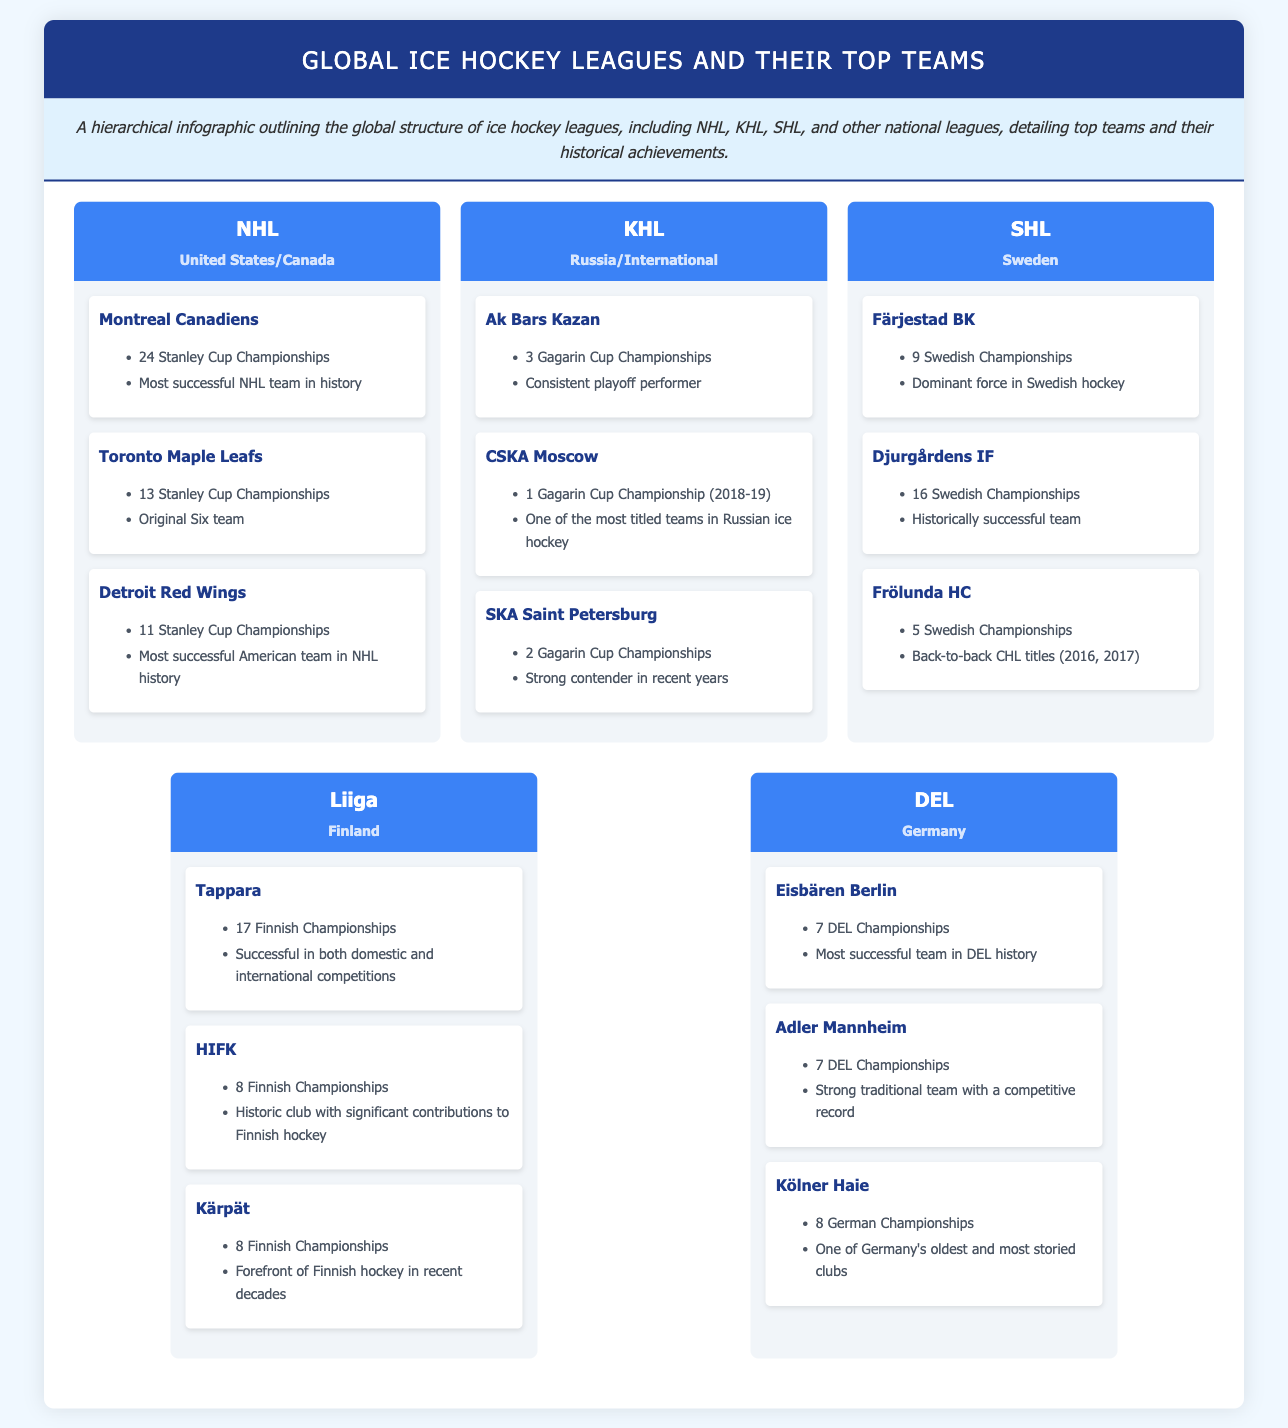What league is known for having 24 Stanley Cup Championships? The document states that the Montreal Canadiens have 24 Stanley Cup Championships, indicating they are part of the NHL.
Answer: Montreal Canadiens Which league is represented by the team Färjestad BK? Färjestad BK is highlighted as part of the SHL, which represents Swedish ice hockey.
Answer: SHL How many Finnish Championships has Tappara won? According to the information, Tappara has won 17 Finnish Championships, which is noted in the document.
Answer: 17 What is the total number of teams listed under the KHL? The document lists three top teams under the KHL, which implies that counting these gives the total number of teams.
Answer: 3 Which country is the DEL league associated with? The document specifies that the DEL league is associated with Germany as its country.
Answer: Germany Which team has the notation "one of the most titled teams in Russian ice hockey"? CSKA Moscow is mentioned in the document as "one of the most titled teams in Russian ice hockey."
Answer: CSKA Moscow Which team is noted for being a consistent playoff performer in the KHL? Ak Bars Kazan is described in the document as a consistent playoff performer in the KHL.
Answer: Ak Bars Kazan How many championships does the team Kölner Haie have? The document notes that Kölner Haie has 8 German Championships listed in their achievements.
Answer: 8 What is the highest number of Swedish Championships held by Djurgårdens IF? Djurgårdens IF has 16 Swedish Championships, as per the achievements detailed in the document.
Answer: 16 